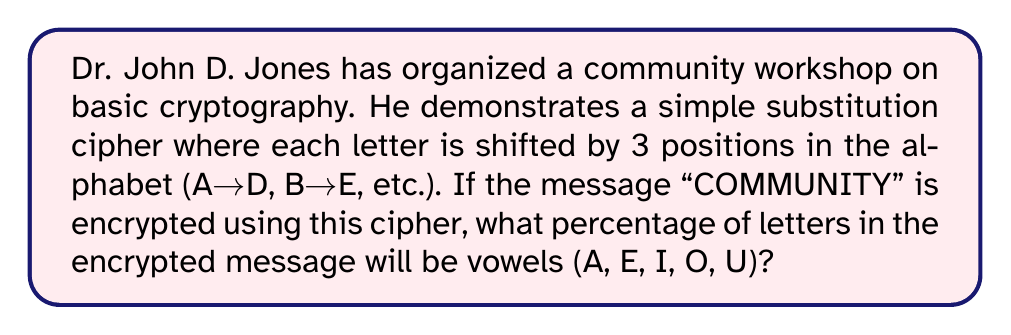Give your solution to this math problem. Let's approach this step-by-step:

1) First, let's encrypt the message "COMMUNITY" using the given cipher:
   C → F
   O → R
   M → P
   M → P
   U → X
   N → Q
   I → L
   T → W
   Y → B

   So, "COMMUNITY" becomes "FRPPXQLWB"

2) Now, let's count the total number of letters in the encrypted message:
   $n_{total} = 9$

3) Next, let's count the number of vowels (A, E, I, O, U) in the encrypted message:
   $n_{vowels} = 0$

4) To calculate the percentage, we use the formula:
   $$ \text{Percentage} = \frac{n_{vowels}}{n_{total}} \times 100\% $$

5) Substituting our values:
   $$ \text{Percentage} = \frac{0}{9} \times 100\% = 0\% $$

This demonstrates that a simple substitution cipher can significantly alter the frequency of vowels in a message, making it less susceptible to frequency analysis attacks.
Answer: 0% 